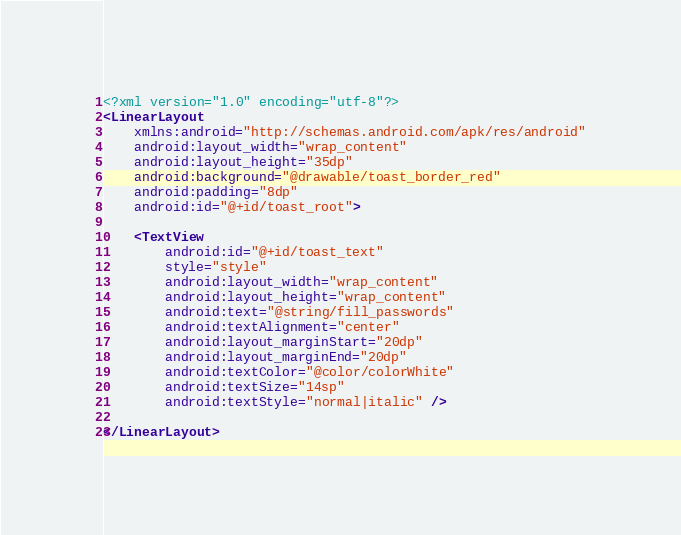<code> <loc_0><loc_0><loc_500><loc_500><_XML_><?xml version="1.0" encoding="utf-8"?>
<LinearLayout
    xmlns:android="http://schemas.android.com/apk/res/android"
    android:layout_width="wrap_content"
    android:layout_height="35dp"
    android:background="@drawable/toast_border_red"
    android:padding="8dp"
    android:id="@+id/toast_root">

    <TextView
        android:id="@+id/toast_text"
        style="style"
        android:layout_width="wrap_content"
        android:layout_height="wrap_content"
        android:text="@string/fill_passwords"
        android:textAlignment="center"
        android:layout_marginStart="20dp"
        android:layout_marginEnd="20dp"
        android:textColor="@color/colorWhite"
        android:textSize="14sp"
        android:textStyle="normal|italic" />

</LinearLayout></code> 